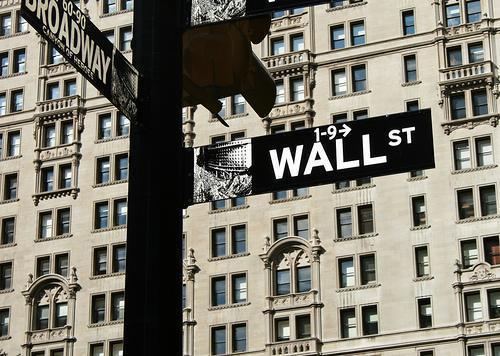How many streets are named?
Give a very brief answer. 2. 